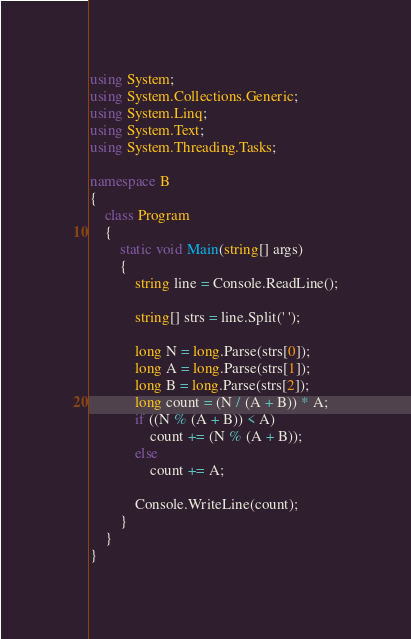<code> <loc_0><loc_0><loc_500><loc_500><_C#_>using System;
using System.Collections.Generic;
using System.Linq;
using System.Text;
using System.Threading.Tasks;

namespace B
{
    class Program
    {
        static void Main(string[] args)
        {
            string line = Console.ReadLine();

            string[] strs = line.Split(' ');

            long N = long.Parse(strs[0]);
            long A = long.Parse(strs[1]);
            long B = long.Parse(strs[2]);
            long count = (N / (A + B)) * A;
            if ((N % (A + B)) < A)
                count += (N % (A + B));
            else
                count += A;

            Console.WriteLine(count);
        }
    }
}
</code> 